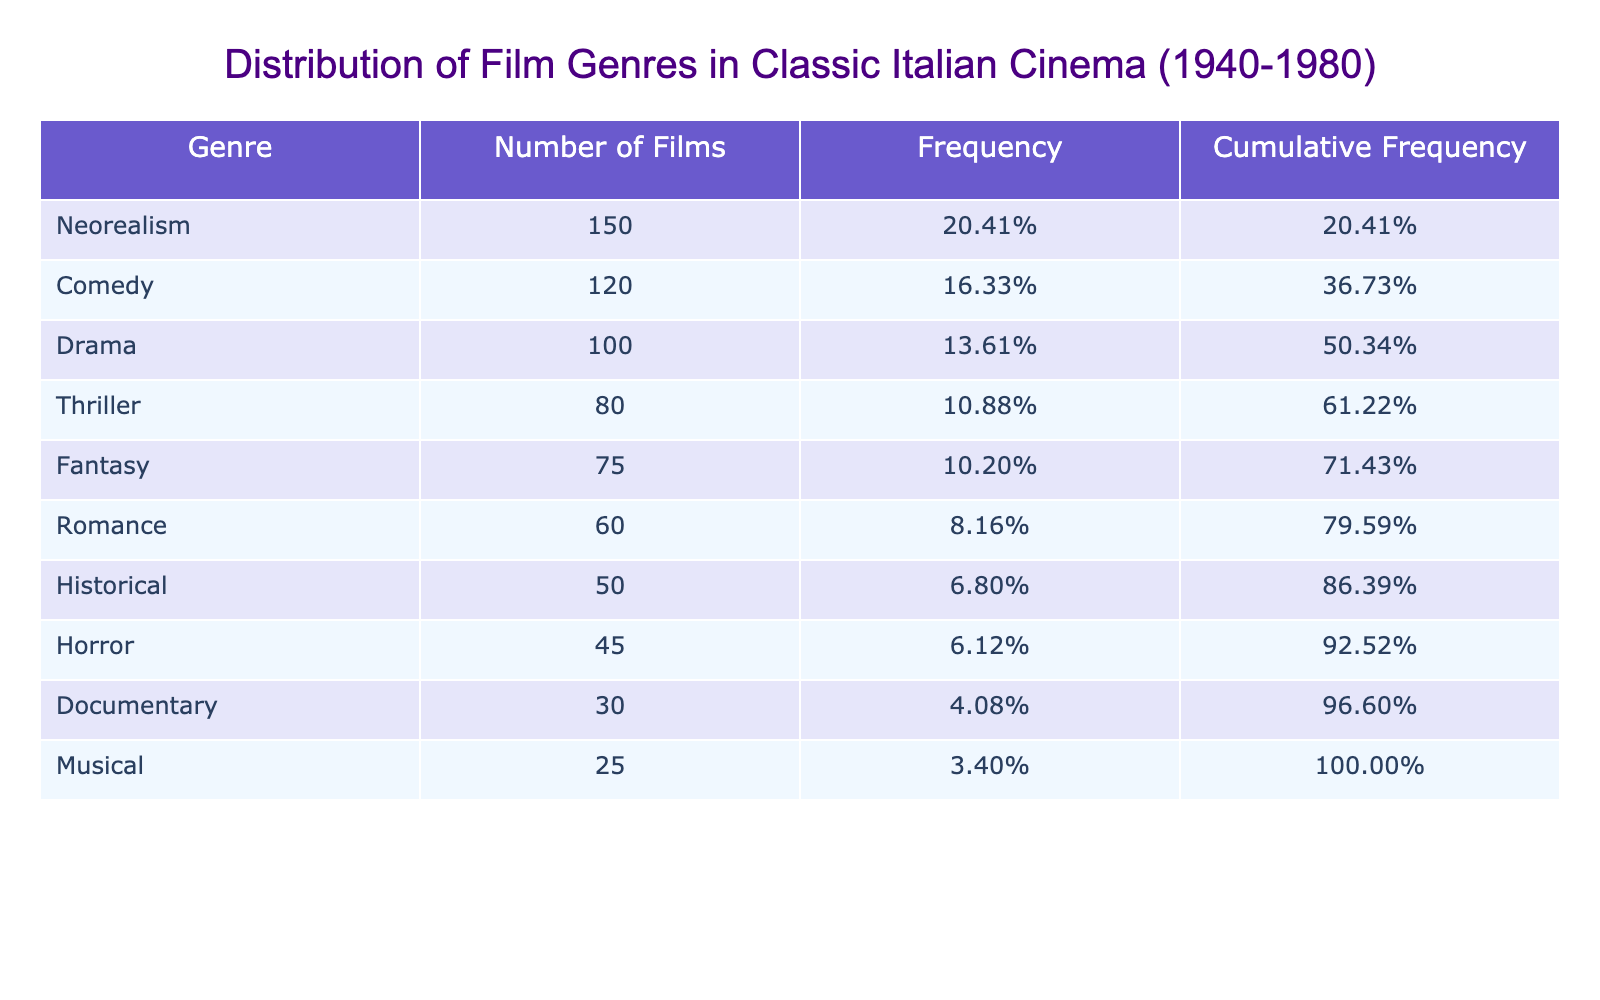What is the genre with the highest number of films? The table shows the different film genres along with their respective number of films. By examining the 'Number of Films' column, it is clear that 'Neorealism' has the highest count at 150.
Answer: Neorealism How many films fall under the 'Comedy' genre? The table lists 'Comedy' along with its corresponding number of films. It indicates that there are 120 films categorized as 'Comedy'.
Answer: 120 Is the number of films in the 'Horror' genre greater than those in 'Musical'? We can compare the values for 'Horror' and 'Musical' genres in the table. 'Horror' has 45 films, while 'Musical' has 25 films. Since 45 is greater than 25, the statement is true.
Answer: Yes What is the total number of films in the 'Drama' and 'Thriller' genres combined? To find the total, we locate the numbers for both 'Drama' (100 films) and 'Thriller' (80 films). Adding them together: 100 + 80 = 180.
Answer: 180 Which genre has the lowest number of films, and how many films does it have? By checking the 'Number of Films' column, 'Musical' has the least films, totaling 25.
Answer: Musical, 25 What percentage of the total films does 'Romance' represent? First, we add up all the films: 150 + 120 + 100 + 75 + 80 + 60 + 50 + 30 + 45 + 25 = 735. The number of 'Romance' films is 60. Therefore, to find the percentage: (60 / 735) * 100 = 8.16%.
Answer: 8.16% How many more films are there in 'Neorealism' than 'Fantasy'? The 'Neorealism' genre has 150 films, and 'Fantasy' has 75. Subtracting these values: 150 - 75 = 75.
Answer: 75 Is the cumulative frequency of 'Historical' films greater than or equal to 10%? The frequency of 'Historical' is calculated as (50 / 735) = 0.068 or 6.8% based on the total of 735 films. Cumulative frequency includes the frequencies of all genres up to 'Historical'. Since it does not reach 10%, the answer is no.
Answer: No What is the average number of films across the genres listed? To compute the average, sum all films (735) and divide by the number of genres (10): 735 / 10 = 73.5.
Answer: 73.5 